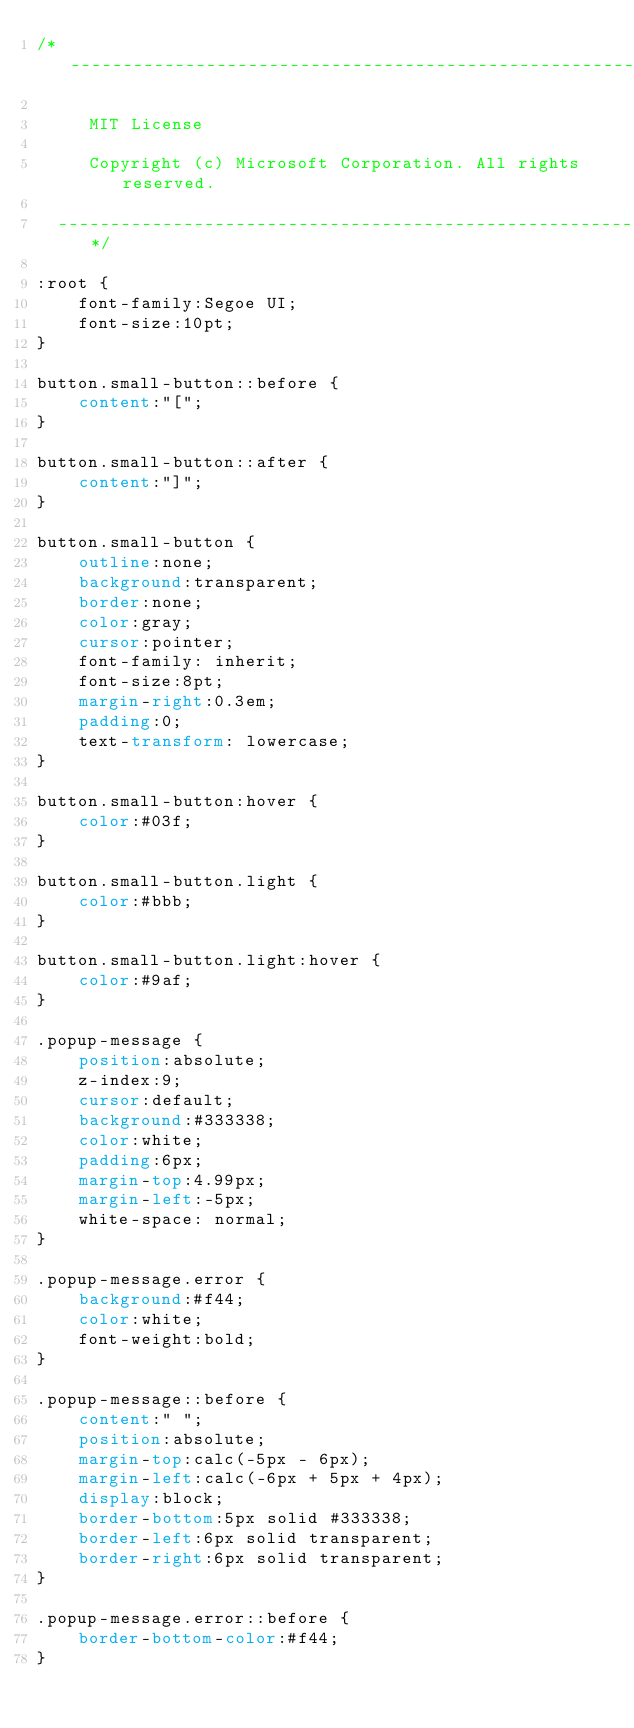<code> <loc_0><loc_0><loc_500><loc_500><_CSS_>/*--------------------------------------------------------------

     MIT License

     Copyright (c) Microsoft Corporation. All rights reserved.

  --------------------------------------------------------------*/

:root {
    font-family:Segoe UI;
    font-size:10pt;
}

button.small-button::before {
    content:"[";
}

button.small-button::after {
    content:"]";
}

button.small-button {
    outline:none;
    background:transparent;
    border:none;
    color:gray;
    cursor:pointer;
    font-family: inherit;
    font-size:8pt;
    margin-right:0.3em;
    padding:0;
    text-transform: lowercase;
}

button.small-button:hover {
    color:#03f;
}

button.small-button.light {
    color:#bbb;
}

button.small-button.light:hover {
    color:#9af;
}

.popup-message {
    position:absolute;
    z-index:9;
    cursor:default;
    background:#333338;
    color:white;
    padding:6px;
    margin-top:4.99px;
    margin-left:-5px;
    white-space: normal;
}

.popup-message.error {
    background:#f44;
    color:white;
    font-weight:bold;
}

.popup-message::before {
    content:" ";
    position:absolute;
    margin-top:calc(-5px - 6px);
    margin-left:calc(-6px + 5px + 4px);
    display:block;
    border-bottom:5px solid #333338;
    border-left:6px solid transparent;
    border-right:6px solid transparent;
}

.popup-message.error::before {
    border-bottom-color:#f44;
}</code> 